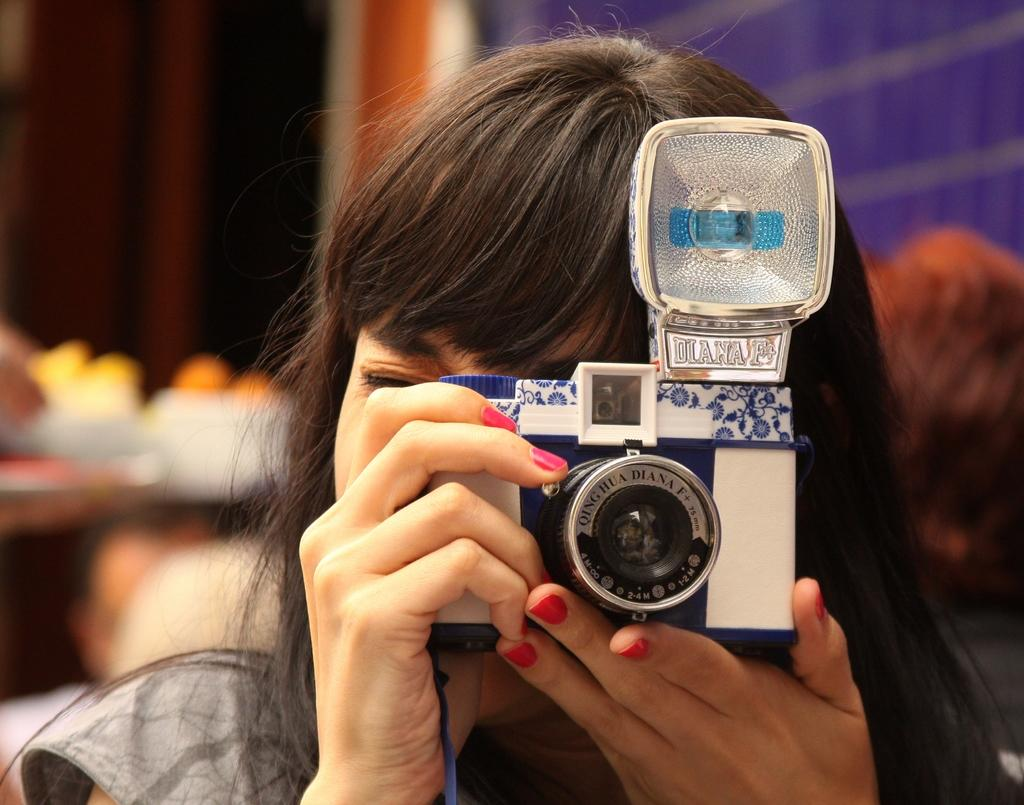Provide a one-sentence caption for the provided image. A woman is holding a Diana F+ camera up to her eye. 